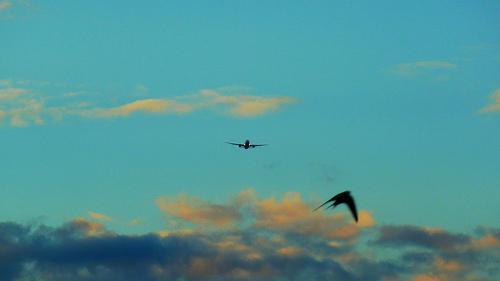How many planes are there?
Give a very brief answer. 1. 